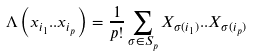Convert formula to latex. <formula><loc_0><loc_0><loc_500><loc_500>\Lambda \left ( x _ { i _ { 1 } } . . x _ { i _ { p } } \right ) = \frac { 1 } { p ! } \sum _ { \sigma \in S _ { p } } X _ { \sigma ( i _ { 1 } ) } . . X _ { \sigma ( i _ { p } ) }</formula> 